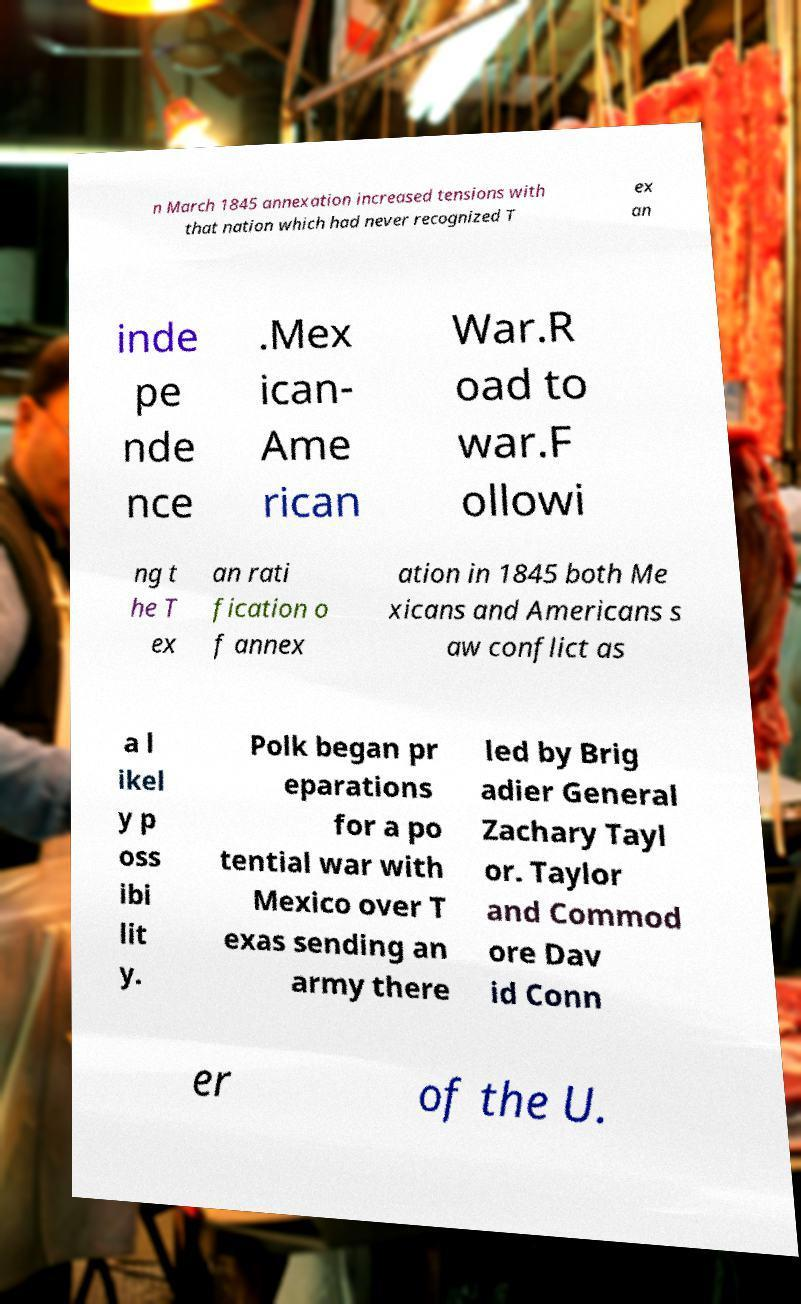Can you read and provide the text displayed in the image?This photo seems to have some interesting text. Can you extract and type it out for me? n March 1845 annexation increased tensions with that nation which had never recognized T ex an inde pe nde nce .Mex ican- Ame rican War.R oad to war.F ollowi ng t he T ex an rati fication o f annex ation in 1845 both Me xicans and Americans s aw conflict as a l ikel y p oss ibi lit y. Polk began pr eparations for a po tential war with Mexico over T exas sending an army there led by Brig adier General Zachary Tayl or. Taylor and Commod ore Dav id Conn er of the U. 